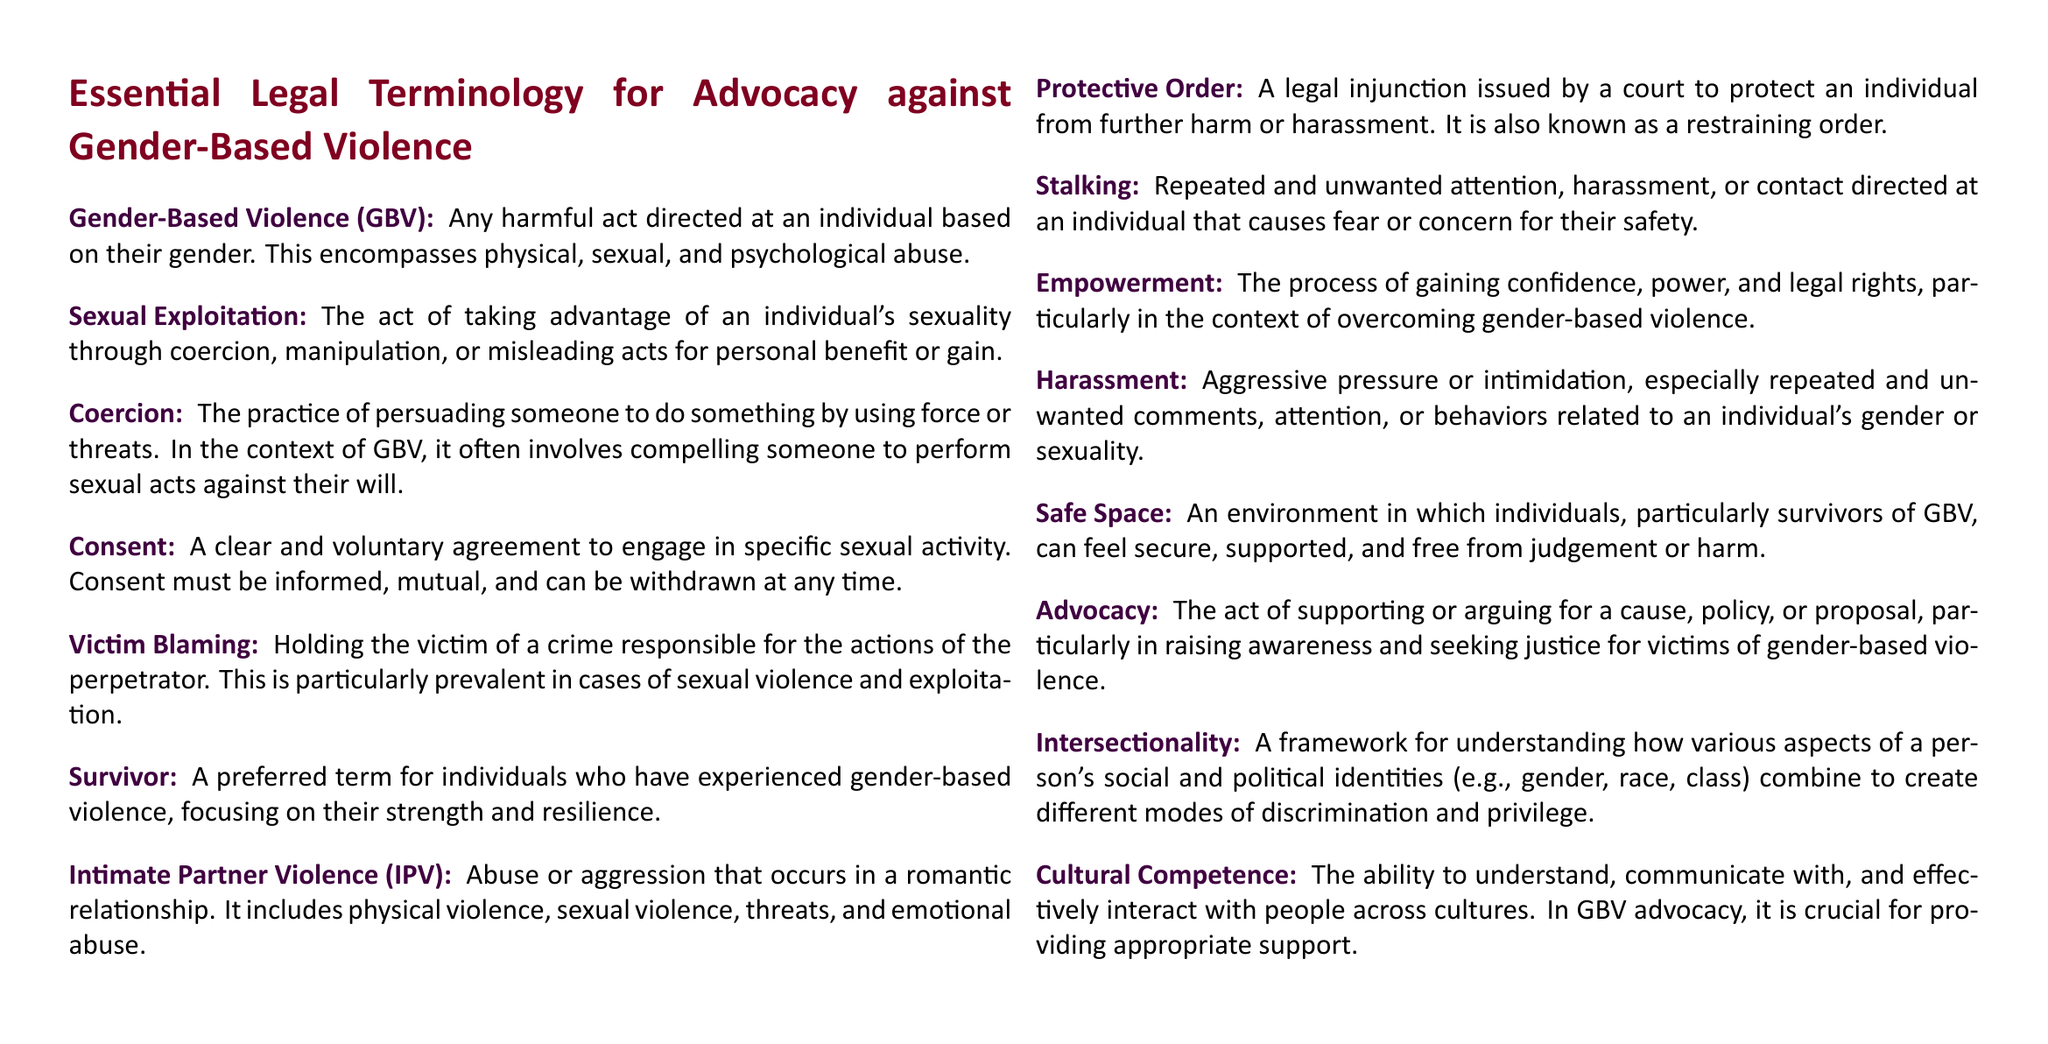What is the definition of Gender-Based Violence? Gender-Based Violence is defined as any harmful act directed at an individual based on their gender.
Answer: harmful act directed at an individual based on their gender What does the term Sexual Exploitation refer to? Sexual Exploitation refers to taking advantage of an individual's sexuality through coercion, manipulation, or misleading acts for personal benefit or gain.
Answer: taking advantage of an individual's sexuality What is a Protective Order? A Protective Order is a legal injunction issued by a court to protect an individual from further harm or harassment.
Answer: legal injunction What does the term Survivor emphasize? The term Survivor emphasizes strength and resilience of individuals who have experienced gender-based violence.
Answer: strength and resilience What is Intersectionality? Intersectionality is a framework for understanding how various aspects of a person's social and political identities combine to create different modes of discrimination and privilege.
Answer: framework for understanding discrimination What is the purpose of Advocacy in the context of gender-based violence? The purpose of Advocacy is to support or argue for a cause, policy, or proposal to raise awareness and seek justice for victims of gender-based violence.
Answer: raise awareness and seek justice What acts are included in Intimate Partner Violence? Intimate Partner Violence includes physical violence, sexual violence, threats, and emotional abuse.
Answer: physical violence, sexual violence, threats, emotional abuse What does Safe Space refer to? Safe Space refers to an environment where individuals, particularly survivors of GBV, feel secure, supported, and free from judgement or harm.
Answer: environment of security and support What does the term Coercion imply in the context of GBV? Coercion implies persuading someone to do something by using force or threats, particularly in the context of GBV.
Answer: persuading by force or threats What is Cultural Competence? Cultural Competence is the ability to understand, communicate with, and effectively interact with people across cultures.
Answer: ability to interact across cultures 